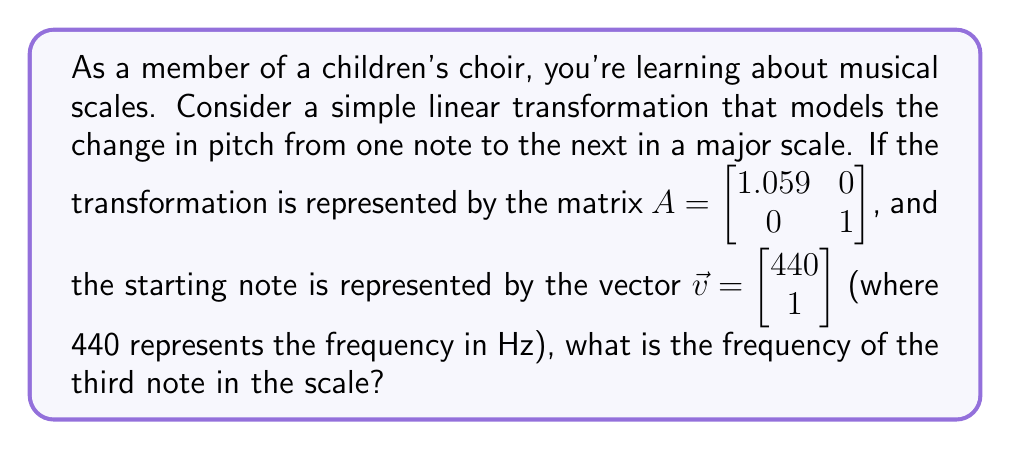Could you help me with this problem? Let's approach this step-by-step:

1) In a major scale, each note is reached by applying the transformation successively. To get to the third note, we need to apply the transformation twice.

2) Mathematically, this is equivalent to multiplying the matrix $A$ by itself, and then multiplying the result by the initial vector $\vec{v}$:

   $A^2\vec{v} = (A \cdot A)\vec{v}$

3) Let's first calculate $A^2$:

   $A^2 = \begin{bmatrix} 1.059 & 0 \\ 0 & 1 \end{bmatrix} \cdot \begin{bmatrix} 1.059 & 0 \\ 0 & 1 \end{bmatrix} = \begin{bmatrix} 1.059^2 & 0 \\ 0 & 1 \end{bmatrix} = \begin{bmatrix} 1.121481 & 0 \\ 0 & 1 \end{bmatrix}$

4) Now, let's multiply this result by $\vec{v}$:

   $A^2\vec{v} = \begin{bmatrix} 1.121481 & 0 \\ 0 & 1 \end{bmatrix} \cdot \begin{bmatrix} 440 \\ 1 \end{bmatrix} = \begin{bmatrix} 1.121481 \cdot 440 \\ 1 \end{bmatrix} = \begin{bmatrix} 493.45164 \\ 1 \end{bmatrix}$

5) The resulting vector gives us the frequency of the third note in the first component.

Therefore, the frequency of the third note is approximately 493.45 Hz.
Answer: 493.45 Hz 